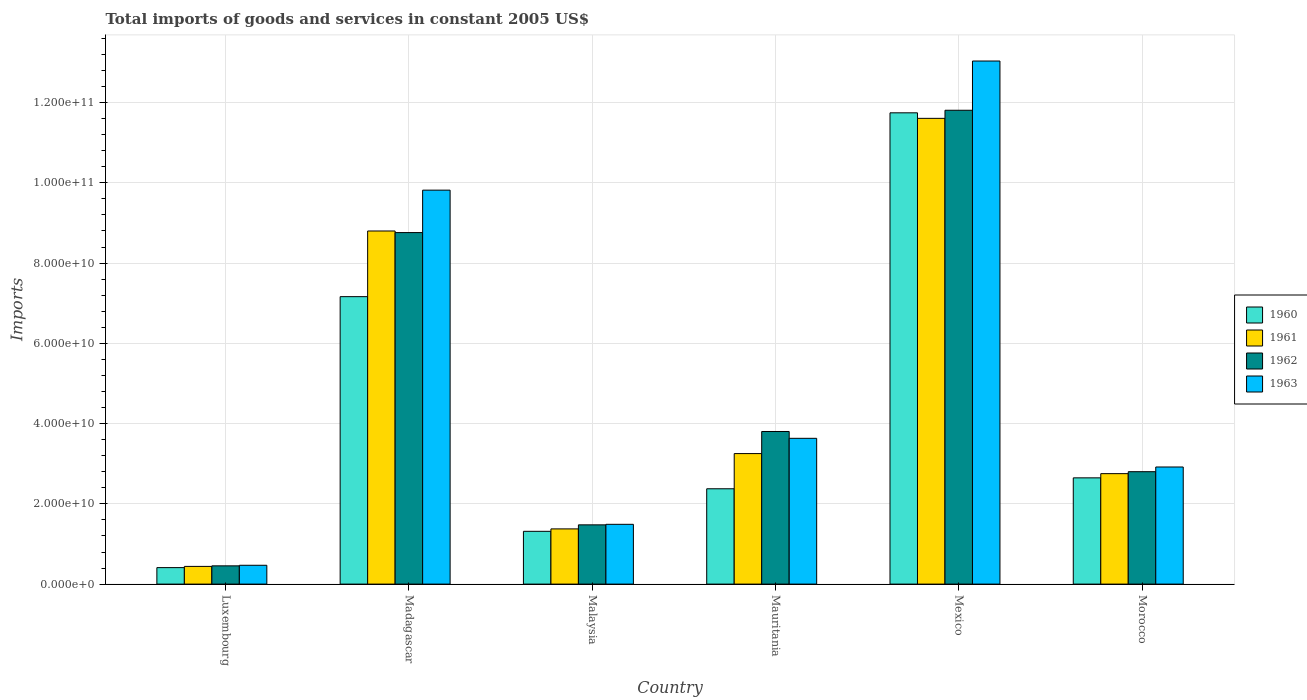How many groups of bars are there?
Offer a very short reply. 6. How many bars are there on the 6th tick from the right?
Ensure brevity in your answer.  4. What is the label of the 4th group of bars from the left?
Keep it short and to the point. Mauritania. What is the total imports of goods and services in 1963 in Morocco?
Give a very brief answer. 2.92e+1. Across all countries, what is the maximum total imports of goods and services in 1962?
Make the answer very short. 1.18e+11. Across all countries, what is the minimum total imports of goods and services in 1961?
Offer a very short reply. 4.41e+09. In which country was the total imports of goods and services in 1961 maximum?
Give a very brief answer. Mexico. In which country was the total imports of goods and services in 1962 minimum?
Ensure brevity in your answer.  Luxembourg. What is the total total imports of goods and services in 1960 in the graph?
Make the answer very short. 2.57e+11. What is the difference between the total imports of goods and services in 1960 in Madagascar and that in Malaysia?
Offer a very short reply. 5.85e+1. What is the difference between the total imports of goods and services in 1962 in Madagascar and the total imports of goods and services in 1960 in Morocco?
Provide a short and direct response. 6.11e+1. What is the average total imports of goods and services in 1962 per country?
Keep it short and to the point. 4.85e+1. What is the difference between the total imports of goods and services of/in 1960 and total imports of goods and services of/in 1962 in Madagascar?
Keep it short and to the point. -1.60e+1. What is the ratio of the total imports of goods and services in 1960 in Malaysia to that in Mauritania?
Provide a short and direct response. 0.55. What is the difference between the highest and the second highest total imports of goods and services in 1962?
Provide a short and direct response. 3.05e+1. What is the difference between the highest and the lowest total imports of goods and services in 1962?
Offer a very short reply. 1.14e+11. In how many countries, is the total imports of goods and services in 1963 greater than the average total imports of goods and services in 1963 taken over all countries?
Keep it short and to the point. 2. Is the sum of the total imports of goods and services in 1960 in Mauritania and Morocco greater than the maximum total imports of goods and services in 1961 across all countries?
Offer a very short reply. No. What does the 4th bar from the right in Mexico represents?
Give a very brief answer. 1960. How many bars are there?
Ensure brevity in your answer.  24. How many countries are there in the graph?
Offer a very short reply. 6. What is the difference between two consecutive major ticks on the Y-axis?
Ensure brevity in your answer.  2.00e+1. Does the graph contain any zero values?
Offer a terse response. No. How many legend labels are there?
Your answer should be very brief. 4. How are the legend labels stacked?
Ensure brevity in your answer.  Vertical. What is the title of the graph?
Keep it short and to the point. Total imports of goods and services in constant 2005 US$. What is the label or title of the Y-axis?
Your answer should be very brief. Imports. What is the Imports of 1960 in Luxembourg?
Give a very brief answer. 4.11e+09. What is the Imports of 1961 in Luxembourg?
Give a very brief answer. 4.41e+09. What is the Imports of 1962 in Luxembourg?
Provide a short and direct response. 4.55e+09. What is the Imports of 1963 in Luxembourg?
Give a very brief answer. 4.69e+09. What is the Imports of 1960 in Madagascar?
Your answer should be very brief. 7.16e+1. What is the Imports in 1961 in Madagascar?
Provide a short and direct response. 8.80e+1. What is the Imports in 1962 in Madagascar?
Your answer should be compact. 8.76e+1. What is the Imports of 1963 in Madagascar?
Provide a succinct answer. 9.82e+1. What is the Imports of 1960 in Malaysia?
Your response must be concise. 1.32e+1. What is the Imports of 1961 in Malaysia?
Ensure brevity in your answer.  1.38e+1. What is the Imports in 1962 in Malaysia?
Offer a terse response. 1.48e+1. What is the Imports of 1963 in Malaysia?
Your response must be concise. 1.49e+1. What is the Imports of 1960 in Mauritania?
Your answer should be very brief. 2.38e+1. What is the Imports in 1961 in Mauritania?
Ensure brevity in your answer.  3.25e+1. What is the Imports in 1962 in Mauritania?
Provide a short and direct response. 3.80e+1. What is the Imports in 1963 in Mauritania?
Ensure brevity in your answer.  3.63e+1. What is the Imports of 1960 in Mexico?
Give a very brief answer. 1.17e+11. What is the Imports in 1961 in Mexico?
Give a very brief answer. 1.16e+11. What is the Imports in 1962 in Mexico?
Your response must be concise. 1.18e+11. What is the Imports of 1963 in Mexico?
Ensure brevity in your answer.  1.30e+11. What is the Imports of 1960 in Morocco?
Keep it short and to the point. 2.65e+1. What is the Imports of 1961 in Morocco?
Ensure brevity in your answer.  2.75e+1. What is the Imports in 1962 in Morocco?
Provide a short and direct response. 2.80e+1. What is the Imports of 1963 in Morocco?
Your answer should be compact. 2.92e+1. Across all countries, what is the maximum Imports of 1960?
Provide a short and direct response. 1.17e+11. Across all countries, what is the maximum Imports in 1961?
Make the answer very short. 1.16e+11. Across all countries, what is the maximum Imports of 1962?
Keep it short and to the point. 1.18e+11. Across all countries, what is the maximum Imports in 1963?
Keep it short and to the point. 1.30e+11. Across all countries, what is the minimum Imports of 1960?
Give a very brief answer. 4.11e+09. Across all countries, what is the minimum Imports in 1961?
Provide a succinct answer. 4.41e+09. Across all countries, what is the minimum Imports in 1962?
Your answer should be very brief. 4.55e+09. Across all countries, what is the minimum Imports of 1963?
Your answer should be compact. 4.69e+09. What is the total Imports in 1960 in the graph?
Ensure brevity in your answer.  2.57e+11. What is the total Imports in 1961 in the graph?
Give a very brief answer. 2.82e+11. What is the total Imports in 1962 in the graph?
Make the answer very short. 2.91e+11. What is the total Imports of 1963 in the graph?
Make the answer very short. 3.14e+11. What is the difference between the Imports in 1960 in Luxembourg and that in Madagascar?
Provide a succinct answer. -6.75e+1. What is the difference between the Imports in 1961 in Luxembourg and that in Madagascar?
Your response must be concise. -8.36e+1. What is the difference between the Imports of 1962 in Luxembourg and that in Madagascar?
Ensure brevity in your answer.  -8.31e+1. What is the difference between the Imports of 1963 in Luxembourg and that in Madagascar?
Provide a short and direct response. -9.35e+1. What is the difference between the Imports in 1960 in Luxembourg and that in Malaysia?
Keep it short and to the point. -9.05e+09. What is the difference between the Imports of 1961 in Luxembourg and that in Malaysia?
Your response must be concise. -9.35e+09. What is the difference between the Imports of 1962 in Luxembourg and that in Malaysia?
Offer a terse response. -1.02e+1. What is the difference between the Imports of 1963 in Luxembourg and that in Malaysia?
Your answer should be compact. -1.02e+1. What is the difference between the Imports of 1960 in Luxembourg and that in Mauritania?
Provide a short and direct response. -1.96e+1. What is the difference between the Imports of 1961 in Luxembourg and that in Mauritania?
Your answer should be very brief. -2.81e+1. What is the difference between the Imports in 1962 in Luxembourg and that in Mauritania?
Make the answer very short. -3.35e+1. What is the difference between the Imports in 1963 in Luxembourg and that in Mauritania?
Your answer should be very brief. -3.16e+1. What is the difference between the Imports of 1960 in Luxembourg and that in Mexico?
Offer a very short reply. -1.13e+11. What is the difference between the Imports in 1961 in Luxembourg and that in Mexico?
Your answer should be compact. -1.12e+11. What is the difference between the Imports in 1962 in Luxembourg and that in Mexico?
Your response must be concise. -1.14e+11. What is the difference between the Imports in 1963 in Luxembourg and that in Mexico?
Your answer should be very brief. -1.26e+11. What is the difference between the Imports of 1960 in Luxembourg and that in Morocco?
Your answer should be compact. -2.24e+1. What is the difference between the Imports in 1961 in Luxembourg and that in Morocco?
Your response must be concise. -2.31e+1. What is the difference between the Imports of 1962 in Luxembourg and that in Morocco?
Keep it short and to the point. -2.35e+1. What is the difference between the Imports of 1963 in Luxembourg and that in Morocco?
Provide a succinct answer. -2.45e+1. What is the difference between the Imports of 1960 in Madagascar and that in Malaysia?
Make the answer very short. 5.85e+1. What is the difference between the Imports of 1961 in Madagascar and that in Malaysia?
Ensure brevity in your answer.  7.42e+1. What is the difference between the Imports of 1962 in Madagascar and that in Malaysia?
Ensure brevity in your answer.  7.28e+1. What is the difference between the Imports of 1963 in Madagascar and that in Malaysia?
Ensure brevity in your answer.  8.33e+1. What is the difference between the Imports of 1960 in Madagascar and that in Mauritania?
Your answer should be compact. 4.79e+1. What is the difference between the Imports of 1961 in Madagascar and that in Mauritania?
Keep it short and to the point. 5.55e+1. What is the difference between the Imports of 1962 in Madagascar and that in Mauritania?
Your response must be concise. 4.96e+1. What is the difference between the Imports in 1963 in Madagascar and that in Mauritania?
Provide a succinct answer. 6.18e+1. What is the difference between the Imports of 1960 in Madagascar and that in Mexico?
Your answer should be compact. -4.58e+1. What is the difference between the Imports of 1961 in Madagascar and that in Mexico?
Give a very brief answer. -2.81e+1. What is the difference between the Imports of 1962 in Madagascar and that in Mexico?
Your answer should be compact. -3.05e+1. What is the difference between the Imports of 1963 in Madagascar and that in Mexico?
Provide a succinct answer. -3.22e+1. What is the difference between the Imports in 1960 in Madagascar and that in Morocco?
Provide a succinct answer. 4.52e+1. What is the difference between the Imports of 1961 in Madagascar and that in Morocco?
Provide a short and direct response. 6.05e+1. What is the difference between the Imports of 1962 in Madagascar and that in Morocco?
Offer a terse response. 5.96e+1. What is the difference between the Imports of 1963 in Madagascar and that in Morocco?
Your answer should be compact. 6.90e+1. What is the difference between the Imports of 1960 in Malaysia and that in Mauritania?
Your response must be concise. -1.06e+1. What is the difference between the Imports of 1961 in Malaysia and that in Mauritania?
Provide a succinct answer. -1.88e+1. What is the difference between the Imports in 1962 in Malaysia and that in Mauritania?
Provide a succinct answer. -2.33e+1. What is the difference between the Imports of 1963 in Malaysia and that in Mauritania?
Provide a succinct answer. -2.14e+1. What is the difference between the Imports of 1960 in Malaysia and that in Mexico?
Offer a terse response. -1.04e+11. What is the difference between the Imports in 1961 in Malaysia and that in Mexico?
Give a very brief answer. -1.02e+11. What is the difference between the Imports in 1962 in Malaysia and that in Mexico?
Provide a short and direct response. -1.03e+11. What is the difference between the Imports in 1963 in Malaysia and that in Mexico?
Give a very brief answer. -1.15e+11. What is the difference between the Imports in 1960 in Malaysia and that in Morocco?
Your answer should be very brief. -1.33e+1. What is the difference between the Imports of 1961 in Malaysia and that in Morocco?
Provide a short and direct response. -1.38e+1. What is the difference between the Imports in 1962 in Malaysia and that in Morocco?
Keep it short and to the point. -1.33e+1. What is the difference between the Imports of 1963 in Malaysia and that in Morocco?
Your answer should be compact. -1.43e+1. What is the difference between the Imports in 1960 in Mauritania and that in Mexico?
Offer a terse response. -9.37e+1. What is the difference between the Imports in 1961 in Mauritania and that in Mexico?
Provide a short and direct response. -8.35e+1. What is the difference between the Imports in 1962 in Mauritania and that in Mexico?
Offer a terse response. -8.01e+1. What is the difference between the Imports in 1963 in Mauritania and that in Mexico?
Offer a terse response. -9.40e+1. What is the difference between the Imports of 1960 in Mauritania and that in Morocco?
Provide a succinct answer. -2.72e+09. What is the difference between the Imports of 1961 in Mauritania and that in Morocco?
Your answer should be compact. 5.00e+09. What is the difference between the Imports of 1962 in Mauritania and that in Morocco?
Make the answer very short. 1.00e+1. What is the difference between the Imports of 1963 in Mauritania and that in Morocco?
Give a very brief answer. 7.15e+09. What is the difference between the Imports of 1960 in Mexico and that in Morocco?
Provide a short and direct response. 9.10e+1. What is the difference between the Imports in 1961 in Mexico and that in Morocco?
Make the answer very short. 8.85e+1. What is the difference between the Imports in 1962 in Mexico and that in Morocco?
Give a very brief answer. 9.01e+1. What is the difference between the Imports of 1963 in Mexico and that in Morocco?
Provide a succinct answer. 1.01e+11. What is the difference between the Imports of 1960 in Luxembourg and the Imports of 1961 in Madagascar?
Offer a terse response. -8.39e+1. What is the difference between the Imports of 1960 in Luxembourg and the Imports of 1962 in Madagascar?
Give a very brief answer. -8.35e+1. What is the difference between the Imports in 1960 in Luxembourg and the Imports in 1963 in Madagascar?
Provide a succinct answer. -9.41e+1. What is the difference between the Imports of 1961 in Luxembourg and the Imports of 1962 in Madagascar?
Provide a succinct answer. -8.32e+1. What is the difference between the Imports in 1961 in Luxembourg and the Imports in 1963 in Madagascar?
Give a very brief answer. -9.38e+1. What is the difference between the Imports in 1962 in Luxembourg and the Imports in 1963 in Madagascar?
Make the answer very short. -9.36e+1. What is the difference between the Imports of 1960 in Luxembourg and the Imports of 1961 in Malaysia?
Keep it short and to the point. -9.65e+09. What is the difference between the Imports in 1960 in Luxembourg and the Imports in 1962 in Malaysia?
Provide a short and direct response. -1.07e+1. What is the difference between the Imports of 1960 in Luxembourg and the Imports of 1963 in Malaysia?
Provide a short and direct response. -1.08e+1. What is the difference between the Imports in 1961 in Luxembourg and the Imports in 1962 in Malaysia?
Make the answer very short. -1.04e+1. What is the difference between the Imports in 1961 in Luxembourg and the Imports in 1963 in Malaysia?
Offer a very short reply. -1.05e+1. What is the difference between the Imports in 1962 in Luxembourg and the Imports in 1963 in Malaysia?
Offer a terse response. -1.03e+1. What is the difference between the Imports in 1960 in Luxembourg and the Imports in 1961 in Mauritania?
Provide a short and direct response. -2.84e+1. What is the difference between the Imports of 1960 in Luxembourg and the Imports of 1962 in Mauritania?
Give a very brief answer. -3.39e+1. What is the difference between the Imports of 1960 in Luxembourg and the Imports of 1963 in Mauritania?
Your answer should be very brief. -3.22e+1. What is the difference between the Imports in 1961 in Luxembourg and the Imports in 1962 in Mauritania?
Ensure brevity in your answer.  -3.36e+1. What is the difference between the Imports of 1961 in Luxembourg and the Imports of 1963 in Mauritania?
Your answer should be compact. -3.19e+1. What is the difference between the Imports in 1962 in Luxembourg and the Imports in 1963 in Mauritania?
Ensure brevity in your answer.  -3.18e+1. What is the difference between the Imports in 1960 in Luxembourg and the Imports in 1961 in Mexico?
Offer a very short reply. -1.12e+11. What is the difference between the Imports in 1960 in Luxembourg and the Imports in 1962 in Mexico?
Make the answer very short. -1.14e+11. What is the difference between the Imports of 1960 in Luxembourg and the Imports of 1963 in Mexico?
Your answer should be very brief. -1.26e+11. What is the difference between the Imports in 1961 in Luxembourg and the Imports in 1962 in Mexico?
Keep it short and to the point. -1.14e+11. What is the difference between the Imports in 1961 in Luxembourg and the Imports in 1963 in Mexico?
Provide a short and direct response. -1.26e+11. What is the difference between the Imports in 1962 in Luxembourg and the Imports in 1963 in Mexico?
Keep it short and to the point. -1.26e+11. What is the difference between the Imports in 1960 in Luxembourg and the Imports in 1961 in Morocco?
Your response must be concise. -2.34e+1. What is the difference between the Imports of 1960 in Luxembourg and the Imports of 1962 in Morocco?
Offer a terse response. -2.39e+1. What is the difference between the Imports in 1960 in Luxembourg and the Imports in 1963 in Morocco?
Your response must be concise. -2.51e+1. What is the difference between the Imports of 1961 in Luxembourg and the Imports of 1962 in Morocco?
Your answer should be compact. -2.36e+1. What is the difference between the Imports of 1961 in Luxembourg and the Imports of 1963 in Morocco?
Make the answer very short. -2.48e+1. What is the difference between the Imports of 1962 in Luxembourg and the Imports of 1963 in Morocco?
Make the answer very short. -2.46e+1. What is the difference between the Imports of 1960 in Madagascar and the Imports of 1961 in Malaysia?
Ensure brevity in your answer.  5.79e+1. What is the difference between the Imports of 1960 in Madagascar and the Imports of 1962 in Malaysia?
Provide a short and direct response. 5.69e+1. What is the difference between the Imports in 1960 in Madagascar and the Imports in 1963 in Malaysia?
Give a very brief answer. 5.67e+1. What is the difference between the Imports of 1961 in Madagascar and the Imports of 1962 in Malaysia?
Keep it short and to the point. 7.32e+1. What is the difference between the Imports in 1961 in Madagascar and the Imports in 1963 in Malaysia?
Your response must be concise. 7.31e+1. What is the difference between the Imports of 1962 in Madagascar and the Imports of 1963 in Malaysia?
Give a very brief answer. 7.27e+1. What is the difference between the Imports of 1960 in Madagascar and the Imports of 1961 in Mauritania?
Offer a very short reply. 3.91e+1. What is the difference between the Imports in 1960 in Madagascar and the Imports in 1962 in Mauritania?
Keep it short and to the point. 3.36e+1. What is the difference between the Imports in 1960 in Madagascar and the Imports in 1963 in Mauritania?
Provide a short and direct response. 3.53e+1. What is the difference between the Imports of 1961 in Madagascar and the Imports of 1962 in Mauritania?
Give a very brief answer. 5.00e+1. What is the difference between the Imports of 1961 in Madagascar and the Imports of 1963 in Mauritania?
Ensure brevity in your answer.  5.17e+1. What is the difference between the Imports of 1962 in Madagascar and the Imports of 1963 in Mauritania?
Ensure brevity in your answer.  5.13e+1. What is the difference between the Imports of 1960 in Madagascar and the Imports of 1961 in Mexico?
Give a very brief answer. -4.44e+1. What is the difference between the Imports of 1960 in Madagascar and the Imports of 1962 in Mexico?
Offer a very short reply. -4.65e+1. What is the difference between the Imports in 1960 in Madagascar and the Imports in 1963 in Mexico?
Offer a very short reply. -5.87e+1. What is the difference between the Imports in 1961 in Madagascar and the Imports in 1962 in Mexico?
Your response must be concise. -3.01e+1. What is the difference between the Imports of 1961 in Madagascar and the Imports of 1963 in Mexico?
Provide a short and direct response. -4.24e+1. What is the difference between the Imports of 1962 in Madagascar and the Imports of 1963 in Mexico?
Offer a terse response. -4.28e+1. What is the difference between the Imports of 1960 in Madagascar and the Imports of 1961 in Morocco?
Offer a terse response. 4.41e+1. What is the difference between the Imports in 1960 in Madagascar and the Imports in 1962 in Morocco?
Offer a very short reply. 4.36e+1. What is the difference between the Imports of 1960 in Madagascar and the Imports of 1963 in Morocco?
Make the answer very short. 4.25e+1. What is the difference between the Imports in 1961 in Madagascar and the Imports in 1962 in Morocco?
Provide a succinct answer. 6.00e+1. What is the difference between the Imports of 1961 in Madagascar and the Imports of 1963 in Morocco?
Make the answer very short. 5.88e+1. What is the difference between the Imports in 1962 in Madagascar and the Imports in 1963 in Morocco?
Provide a short and direct response. 5.84e+1. What is the difference between the Imports in 1960 in Malaysia and the Imports in 1961 in Mauritania?
Offer a very short reply. -1.94e+1. What is the difference between the Imports in 1960 in Malaysia and the Imports in 1962 in Mauritania?
Offer a terse response. -2.49e+1. What is the difference between the Imports in 1960 in Malaysia and the Imports in 1963 in Mauritania?
Make the answer very short. -2.32e+1. What is the difference between the Imports in 1961 in Malaysia and the Imports in 1962 in Mauritania?
Your response must be concise. -2.43e+1. What is the difference between the Imports in 1961 in Malaysia and the Imports in 1963 in Mauritania?
Give a very brief answer. -2.26e+1. What is the difference between the Imports of 1962 in Malaysia and the Imports of 1963 in Mauritania?
Your answer should be very brief. -2.16e+1. What is the difference between the Imports in 1960 in Malaysia and the Imports in 1961 in Mexico?
Offer a terse response. -1.03e+11. What is the difference between the Imports in 1960 in Malaysia and the Imports in 1962 in Mexico?
Your answer should be very brief. -1.05e+11. What is the difference between the Imports of 1960 in Malaysia and the Imports of 1963 in Mexico?
Provide a short and direct response. -1.17e+11. What is the difference between the Imports of 1961 in Malaysia and the Imports of 1962 in Mexico?
Make the answer very short. -1.04e+11. What is the difference between the Imports of 1961 in Malaysia and the Imports of 1963 in Mexico?
Keep it short and to the point. -1.17e+11. What is the difference between the Imports of 1962 in Malaysia and the Imports of 1963 in Mexico?
Give a very brief answer. -1.16e+11. What is the difference between the Imports of 1960 in Malaysia and the Imports of 1961 in Morocco?
Offer a very short reply. -1.44e+1. What is the difference between the Imports in 1960 in Malaysia and the Imports in 1962 in Morocco?
Your answer should be compact. -1.49e+1. What is the difference between the Imports in 1960 in Malaysia and the Imports in 1963 in Morocco?
Ensure brevity in your answer.  -1.60e+1. What is the difference between the Imports in 1961 in Malaysia and the Imports in 1962 in Morocco?
Provide a short and direct response. -1.43e+1. What is the difference between the Imports of 1961 in Malaysia and the Imports of 1963 in Morocco?
Give a very brief answer. -1.54e+1. What is the difference between the Imports in 1962 in Malaysia and the Imports in 1963 in Morocco?
Your answer should be compact. -1.44e+1. What is the difference between the Imports of 1960 in Mauritania and the Imports of 1961 in Mexico?
Your answer should be very brief. -9.23e+1. What is the difference between the Imports in 1960 in Mauritania and the Imports in 1962 in Mexico?
Provide a succinct answer. -9.43e+1. What is the difference between the Imports of 1960 in Mauritania and the Imports of 1963 in Mexico?
Give a very brief answer. -1.07e+11. What is the difference between the Imports of 1961 in Mauritania and the Imports of 1962 in Mexico?
Keep it short and to the point. -8.56e+1. What is the difference between the Imports of 1961 in Mauritania and the Imports of 1963 in Mexico?
Make the answer very short. -9.78e+1. What is the difference between the Imports in 1962 in Mauritania and the Imports in 1963 in Mexico?
Make the answer very short. -9.23e+1. What is the difference between the Imports of 1960 in Mauritania and the Imports of 1961 in Morocco?
Your answer should be very brief. -3.77e+09. What is the difference between the Imports in 1960 in Mauritania and the Imports in 1962 in Morocco?
Offer a very short reply. -4.26e+09. What is the difference between the Imports of 1960 in Mauritania and the Imports of 1963 in Morocco?
Keep it short and to the point. -5.43e+09. What is the difference between the Imports of 1961 in Mauritania and the Imports of 1962 in Morocco?
Provide a succinct answer. 4.51e+09. What is the difference between the Imports of 1961 in Mauritania and the Imports of 1963 in Morocco?
Your answer should be very brief. 3.34e+09. What is the difference between the Imports in 1962 in Mauritania and the Imports in 1963 in Morocco?
Provide a succinct answer. 8.85e+09. What is the difference between the Imports of 1960 in Mexico and the Imports of 1961 in Morocco?
Offer a terse response. 8.99e+1. What is the difference between the Imports of 1960 in Mexico and the Imports of 1962 in Morocco?
Your response must be concise. 8.94e+1. What is the difference between the Imports of 1960 in Mexico and the Imports of 1963 in Morocco?
Keep it short and to the point. 8.83e+1. What is the difference between the Imports of 1961 in Mexico and the Imports of 1962 in Morocco?
Keep it short and to the point. 8.81e+1. What is the difference between the Imports in 1961 in Mexico and the Imports in 1963 in Morocco?
Keep it short and to the point. 8.69e+1. What is the difference between the Imports of 1962 in Mexico and the Imports of 1963 in Morocco?
Your answer should be compact. 8.89e+1. What is the average Imports in 1960 per country?
Provide a succinct answer. 4.28e+1. What is the average Imports of 1961 per country?
Your answer should be compact. 4.70e+1. What is the average Imports in 1962 per country?
Keep it short and to the point. 4.85e+1. What is the average Imports of 1963 per country?
Provide a short and direct response. 5.23e+1. What is the difference between the Imports in 1960 and Imports in 1961 in Luxembourg?
Offer a very short reply. -3.01e+08. What is the difference between the Imports of 1960 and Imports of 1962 in Luxembourg?
Ensure brevity in your answer.  -4.41e+08. What is the difference between the Imports in 1960 and Imports in 1963 in Luxembourg?
Make the answer very short. -5.83e+08. What is the difference between the Imports of 1961 and Imports of 1962 in Luxembourg?
Keep it short and to the point. -1.40e+08. What is the difference between the Imports of 1961 and Imports of 1963 in Luxembourg?
Offer a terse response. -2.82e+08. What is the difference between the Imports in 1962 and Imports in 1963 in Luxembourg?
Keep it short and to the point. -1.42e+08. What is the difference between the Imports in 1960 and Imports in 1961 in Madagascar?
Your answer should be compact. -1.64e+1. What is the difference between the Imports of 1960 and Imports of 1962 in Madagascar?
Ensure brevity in your answer.  -1.60e+1. What is the difference between the Imports in 1960 and Imports in 1963 in Madagascar?
Your response must be concise. -2.65e+1. What is the difference between the Imports in 1961 and Imports in 1962 in Madagascar?
Offer a very short reply. 3.99e+08. What is the difference between the Imports in 1961 and Imports in 1963 in Madagascar?
Your answer should be very brief. -1.02e+1. What is the difference between the Imports in 1962 and Imports in 1963 in Madagascar?
Provide a succinct answer. -1.06e+1. What is the difference between the Imports of 1960 and Imports of 1961 in Malaysia?
Provide a succinct answer. -6.03e+08. What is the difference between the Imports of 1960 and Imports of 1962 in Malaysia?
Your answer should be very brief. -1.61e+09. What is the difference between the Imports in 1960 and Imports in 1963 in Malaysia?
Offer a very short reply. -1.74e+09. What is the difference between the Imports in 1961 and Imports in 1962 in Malaysia?
Make the answer very short. -1.01e+09. What is the difference between the Imports of 1961 and Imports of 1963 in Malaysia?
Your answer should be compact. -1.14e+09. What is the difference between the Imports of 1962 and Imports of 1963 in Malaysia?
Your response must be concise. -1.35e+08. What is the difference between the Imports of 1960 and Imports of 1961 in Mauritania?
Your response must be concise. -8.77e+09. What is the difference between the Imports in 1960 and Imports in 1962 in Mauritania?
Your answer should be very brief. -1.43e+1. What is the difference between the Imports of 1960 and Imports of 1963 in Mauritania?
Provide a short and direct response. -1.26e+1. What is the difference between the Imports in 1961 and Imports in 1962 in Mauritania?
Make the answer very short. -5.50e+09. What is the difference between the Imports in 1961 and Imports in 1963 in Mauritania?
Offer a very short reply. -3.80e+09. What is the difference between the Imports of 1962 and Imports of 1963 in Mauritania?
Offer a very short reply. 1.70e+09. What is the difference between the Imports of 1960 and Imports of 1961 in Mexico?
Provide a short and direct response. 1.38e+09. What is the difference between the Imports in 1960 and Imports in 1962 in Mexico?
Make the answer very short. -6.38e+08. What is the difference between the Imports of 1960 and Imports of 1963 in Mexico?
Your answer should be very brief. -1.29e+1. What is the difference between the Imports of 1961 and Imports of 1962 in Mexico?
Make the answer very short. -2.02e+09. What is the difference between the Imports of 1961 and Imports of 1963 in Mexico?
Your answer should be compact. -1.43e+1. What is the difference between the Imports in 1962 and Imports in 1963 in Mexico?
Provide a succinct answer. -1.23e+1. What is the difference between the Imports of 1960 and Imports of 1961 in Morocco?
Give a very brief answer. -1.05e+09. What is the difference between the Imports in 1960 and Imports in 1962 in Morocco?
Offer a very short reply. -1.54e+09. What is the difference between the Imports in 1960 and Imports in 1963 in Morocco?
Provide a short and direct response. -2.70e+09. What is the difference between the Imports in 1961 and Imports in 1962 in Morocco?
Ensure brevity in your answer.  -4.88e+08. What is the difference between the Imports in 1961 and Imports in 1963 in Morocco?
Offer a terse response. -1.66e+09. What is the difference between the Imports of 1962 and Imports of 1963 in Morocco?
Your answer should be compact. -1.17e+09. What is the ratio of the Imports of 1960 in Luxembourg to that in Madagascar?
Keep it short and to the point. 0.06. What is the ratio of the Imports in 1961 in Luxembourg to that in Madagascar?
Give a very brief answer. 0.05. What is the ratio of the Imports in 1962 in Luxembourg to that in Madagascar?
Offer a terse response. 0.05. What is the ratio of the Imports of 1963 in Luxembourg to that in Madagascar?
Your answer should be very brief. 0.05. What is the ratio of the Imports of 1960 in Luxembourg to that in Malaysia?
Your answer should be very brief. 0.31. What is the ratio of the Imports in 1961 in Luxembourg to that in Malaysia?
Your answer should be very brief. 0.32. What is the ratio of the Imports of 1962 in Luxembourg to that in Malaysia?
Give a very brief answer. 0.31. What is the ratio of the Imports of 1963 in Luxembourg to that in Malaysia?
Offer a very short reply. 0.31. What is the ratio of the Imports of 1960 in Luxembourg to that in Mauritania?
Your response must be concise. 0.17. What is the ratio of the Imports of 1961 in Luxembourg to that in Mauritania?
Your response must be concise. 0.14. What is the ratio of the Imports in 1962 in Luxembourg to that in Mauritania?
Provide a short and direct response. 0.12. What is the ratio of the Imports of 1963 in Luxembourg to that in Mauritania?
Your response must be concise. 0.13. What is the ratio of the Imports in 1960 in Luxembourg to that in Mexico?
Keep it short and to the point. 0.04. What is the ratio of the Imports of 1961 in Luxembourg to that in Mexico?
Ensure brevity in your answer.  0.04. What is the ratio of the Imports in 1962 in Luxembourg to that in Mexico?
Your answer should be compact. 0.04. What is the ratio of the Imports in 1963 in Luxembourg to that in Mexico?
Give a very brief answer. 0.04. What is the ratio of the Imports of 1960 in Luxembourg to that in Morocco?
Offer a terse response. 0.16. What is the ratio of the Imports of 1961 in Luxembourg to that in Morocco?
Make the answer very short. 0.16. What is the ratio of the Imports of 1962 in Luxembourg to that in Morocco?
Your answer should be very brief. 0.16. What is the ratio of the Imports in 1963 in Luxembourg to that in Morocco?
Ensure brevity in your answer.  0.16. What is the ratio of the Imports of 1960 in Madagascar to that in Malaysia?
Your answer should be compact. 5.45. What is the ratio of the Imports in 1961 in Madagascar to that in Malaysia?
Offer a terse response. 6.4. What is the ratio of the Imports in 1962 in Madagascar to that in Malaysia?
Your answer should be very brief. 5.93. What is the ratio of the Imports of 1963 in Madagascar to that in Malaysia?
Offer a very short reply. 6.59. What is the ratio of the Imports of 1960 in Madagascar to that in Mauritania?
Make the answer very short. 3.02. What is the ratio of the Imports in 1961 in Madagascar to that in Mauritania?
Ensure brevity in your answer.  2.71. What is the ratio of the Imports in 1962 in Madagascar to that in Mauritania?
Your answer should be compact. 2.3. What is the ratio of the Imports in 1963 in Madagascar to that in Mauritania?
Provide a short and direct response. 2.7. What is the ratio of the Imports of 1960 in Madagascar to that in Mexico?
Offer a terse response. 0.61. What is the ratio of the Imports in 1961 in Madagascar to that in Mexico?
Ensure brevity in your answer.  0.76. What is the ratio of the Imports in 1962 in Madagascar to that in Mexico?
Provide a short and direct response. 0.74. What is the ratio of the Imports of 1963 in Madagascar to that in Mexico?
Offer a terse response. 0.75. What is the ratio of the Imports of 1960 in Madagascar to that in Morocco?
Your answer should be compact. 2.71. What is the ratio of the Imports in 1961 in Madagascar to that in Morocco?
Give a very brief answer. 3.2. What is the ratio of the Imports of 1962 in Madagascar to that in Morocco?
Your answer should be very brief. 3.13. What is the ratio of the Imports of 1963 in Madagascar to that in Morocco?
Offer a very short reply. 3.36. What is the ratio of the Imports in 1960 in Malaysia to that in Mauritania?
Provide a succinct answer. 0.55. What is the ratio of the Imports of 1961 in Malaysia to that in Mauritania?
Provide a succinct answer. 0.42. What is the ratio of the Imports of 1962 in Malaysia to that in Mauritania?
Ensure brevity in your answer.  0.39. What is the ratio of the Imports of 1963 in Malaysia to that in Mauritania?
Give a very brief answer. 0.41. What is the ratio of the Imports of 1960 in Malaysia to that in Mexico?
Provide a succinct answer. 0.11. What is the ratio of the Imports of 1961 in Malaysia to that in Mexico?
Ensure brevity in your answer.  0.12. What is the ratio of the Imports in 1963 in Malaysia to that in Mexico?
Provide a succinct answer. 0.11. What is the ratio of the Imports in 1960 in Malaysia to that in Morocco?
Provide a short and direct response. 0.5. What is the ratio of the Imports in 1961 in Malaysia to that in Morocco?
Provide a short and direct response. 0.5. What is the ratio of the Imports of 1962 in Malaysia to that in Morocco?
Provide a short and direct response. 0.53. What is the ratio of the Imports in 1963 in Malaysia to that in Morocco?
Keep it short and to the point. 0.51. What is the ratio of the Imports of 1960 in Mauritania to that in Mexico?
Make the answer very short. 0.2. What is the ratio of the Imports of 1961 in Mauritania to that in Mexico?
Make the answer very short. 0.28. What is the ratio of the Imports in 1962 in Mauritania to that in Mexico?
Provide a succinct answer. 0.32. What is the ratio of the Imports in 1963 in Mauritania to that in Mexico?
Your answer should be very brief. 0.28. What is the ratio of the Imports of 1960 in Mauritania to that in Morocco?
Offer a very short reply. 0.9. What is the ratio of the Imports of 1961 in Mauritania to that in Morocco?
Make the answer very short. 1.18. What is the ratio of the Imports of 1962 in Mauritania to that in Morocco?
Your response must be concise. 1.36. What is the ratio of the Imports of 1963 in Mauritania to that in Morocco?
Keep it short and to the point. 1.24. What is the ratio of the Imports in 1960 in Mexico to that in Morocco?
Offer a terse response. 4.44. What is the ratio of the Imports of 1961 in Mexico to that in Morocco?
Provide a short and direct response. 4.22. What is the ratio of the Imports of 1962 in Mexico to that in Morocco?
Offer a terse response. 4.22. What is the ratio of the Imports of 1963 in Mexico to that in Morocco?
Your response must be concise. 4.47. What is the difference between the highest and the second highest Imports in 1960?
Provide a short and direct response. 4.58e+1. What is the difference between the highest and the second highest Imports of 1961?
Provide a succinct answer. 2.81e+1. What is the difference between the highest and the second highest Imports in 1962?
Offer a very short reply. 3.05e+1. What is the difference between the highest and the second highest Imports of 1963?
Your answer should be very brief. 3.22e+1. What is the difference between the highest and the lowest Imports in 1960?
Provide a short and direct response. 1.13e+11. What is the difference between the highest and the lowest Imports of 1961?
Your response must be concise. 1.12e+11. What is the difference between the highest and the lowest Imports in 1962?
Your answer should be very brief. 1.14e+11. What is the difference between the highest and the lowest Imports of 1963?
Your response must be concise. 1.26e+11. 